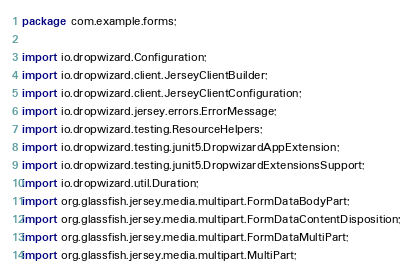Convert code to text. <code><loc_0><loc_0><loc_500><loc_500><_Java_>package com.example.forms;

import io.dropwizard.Configuration;
import io.dropwizard.client.JerseyClientBuilder;
import io.dropwizard.client.JerseyClientConfiguration;
import io.dropwizard.jersey.errors.ErrorMessage;
import io.dropwizard.testing.ResourceHelpers;
import io.dropwizard.testing.junit5.DropwizardAppExtension;
import io.dropwizard.testing.junit5.DropwizardExtensionsSupport;
import io.dropwizard.util.Duration;
import org.glassfish.jersey.media.multipart.FormDataBodyPart;
import org.glassfish.jersey.media.multipart.FormDataContentDisposition;
import org.glassfish.jersey.media.multipart.FormDataMultiPart;
import org.glassfish.jersey.media.multipart.MultiPart;</code> 